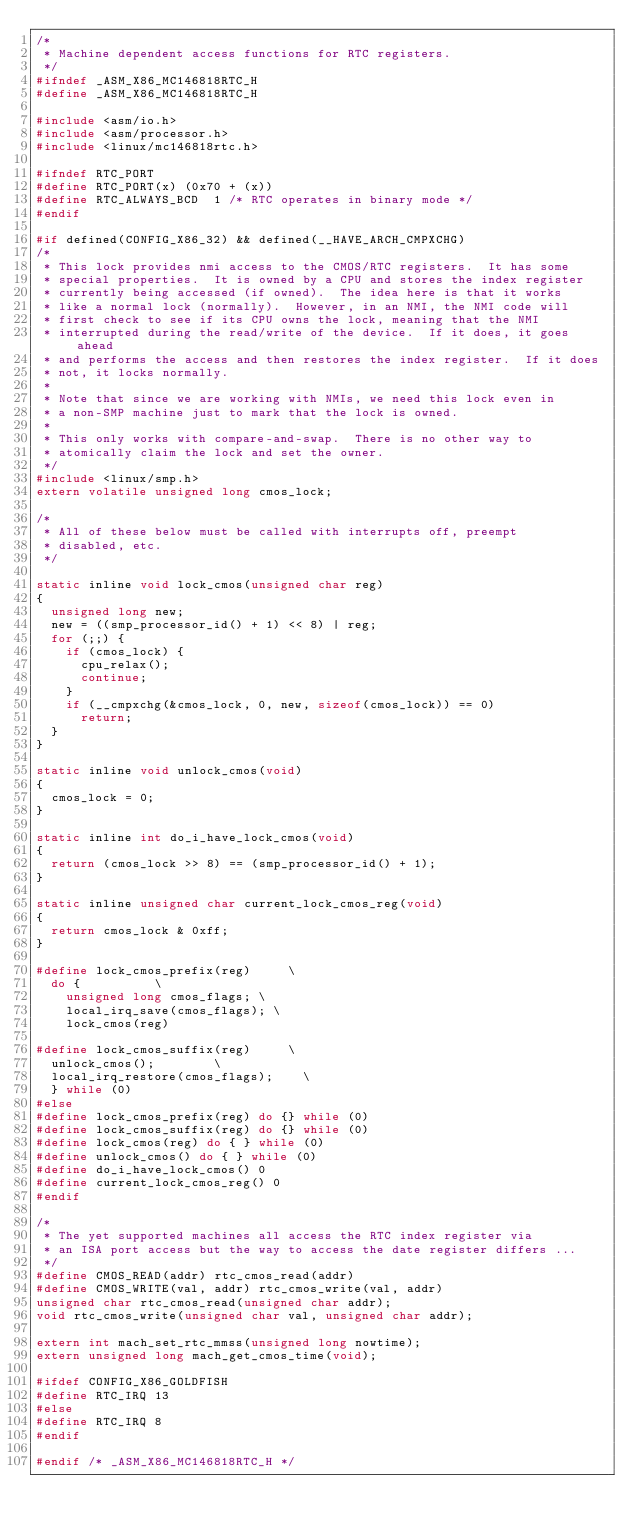<code> <loc_0><loc_0><loc_500><loc_500><_C_>/*
 * Machine dependent access functions for RTC registers.
 */
#ifndef _ASM_X86_MC146818RTC_H
#define _ASM_X86_MC146818RTC_H

#include <asm/io.h>
#include <asm/processor.h>
#include <linux/mc146818rtc.h>

#ifndef RTC_PORT
#define RTC_PORT(x)	(0x70 + (x))
#define RTC_ALWAYS_BCD	1	/* RTC operates in binary mode */
#endif

#if defined(CONFIG_X86_32) && defined(__HAVE_ARCH_CMPXCHG)
/*
 * This lock provides nmi access to the CMOS/RTC registers.  It has some
 * special properties.  It is owned by a CPU and stores the index register
 * currently being accessed (if owned).  The idea here is that it works
 * like a normal lock (normally).  However, in an NMI, the NMI code will
 * first check to see if its CPU owns the lock, meaning that the NMI
 * interrupted during the read/write of the device.  If it does, it goes ahead
 * and performs the access and then restores the index register.  If it does
 * not, it locks normally.
 *
 * Note that since we are working with NMIs, we need this lock even in
 * a non-SMP machine just to mark that the lock is owned.
 *
 * This only works with compare-and-swap.  There is no other way to
 * atomically claim the lock and set the owner.
 */
#include <linux/smp.h>
extern volatile unsigned long cmos_lock;

/*
 * All of these below must be called with interrupts off, preempt
 * disabled, etc.
 */

static inline void lock_cmos(unsigned char reg)
{
	unsigned long new;
	new = ((smp_processor_id() + 1) << 8) | reg;
	for (;;) {
		if (cmos_lock) {
			cpu_relax();
			continue;
		}
		if (__cmpxchg(&cmos_lock, 0, new, sizeof(cmos_lock)) == 0)
			return;
	}
}

static inline void unlock_cmos(void)
{
	cmos_lock = 0;
}

static inline int do_i_have_lock_cmos(void)
{
	return (cmos_lock >> 8) == (smp_processor_id() + 1);
}

static inline unsigned char current_lock_cmos_reg(void)
{
	return cmos_lock & 0xff;
}

#define lock_cmos_prefix(reg)			\
	do {					\
		unsigned long cmos_flags;	\
		local_irq_save(cmos_flags);	\
		lock_cmos(reg)

#define lock_cmos_suffix(reg)			\
	unlock_cmos();				\
	local_irq_restore(cmos_flags);		\
	} while (0)
#else
#define lock_cmos_prefix(reg) do {} while (0)
#define lock_cmos_suffix(reg) do {} while (0)
#define lock_cmos(reg) do { } while (0)
#define unlock_cmos() do { } while (0)
#define do_i_have_lock_cmos() 0
#define current_lock_cmos_reg() 0
#endif

/*
 * The yet supported machines all access the RTC index register via
 * an ISA port access but the way to access the date register differs ...
 */
#define CMOS_READ(addr) rtc_cmos_read(addr)
#define CMOS_WRITE(val, addr) rtc_cmos_write(val, addr)
unsigned char rtc_cmos_read(unsigned char addr);
void rtc_cmos_write(unsigned char val, unsigned char addr);

extern int mach_set_rtc_mmss(unsigned long nowtime);
extern unsigned long mach_get_cmos_time(void);

#ifdef CONFIG_X86_GOLDFISH
#define RTC_IRQ 13
#else
#define RTC_IRQ 8
#endif

#endif /* _ASM_X86_MC146818RTC_H */
</code> 